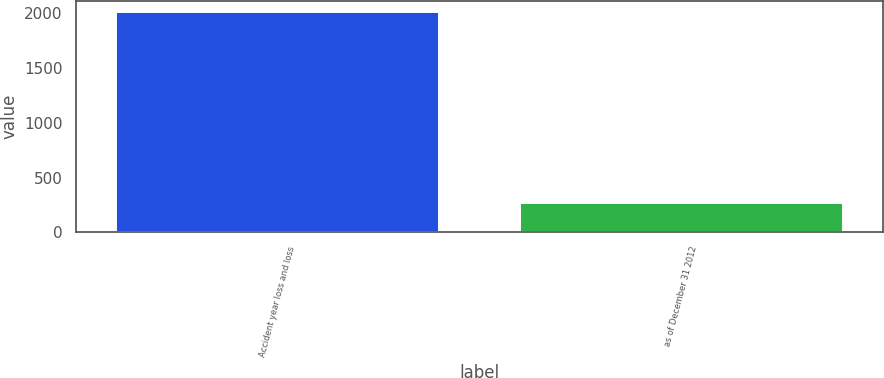Convert chart. <chart><loc_0><loc_0><loc_500><loc_500><bar_chart><fcel>Accident year loss and loss<fcel>as of December 31 2012<nl><fcel>2010<fcel>271<nl></chart> 